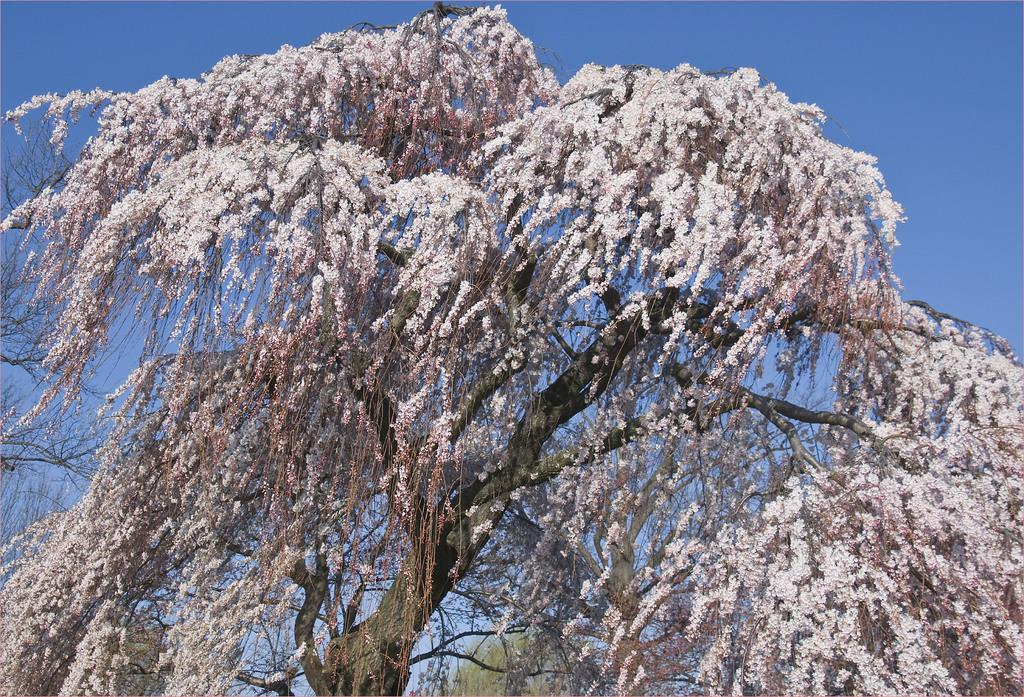What type of plant can be seen in the image? There is a tree in the image. What additional feature can be observed on the tree? The tree has flowers on it. What type of agreement is being discussed by the flowers on the tree in the image? There is no indication in the image that the flowers on the tree are discussing any agreement. 